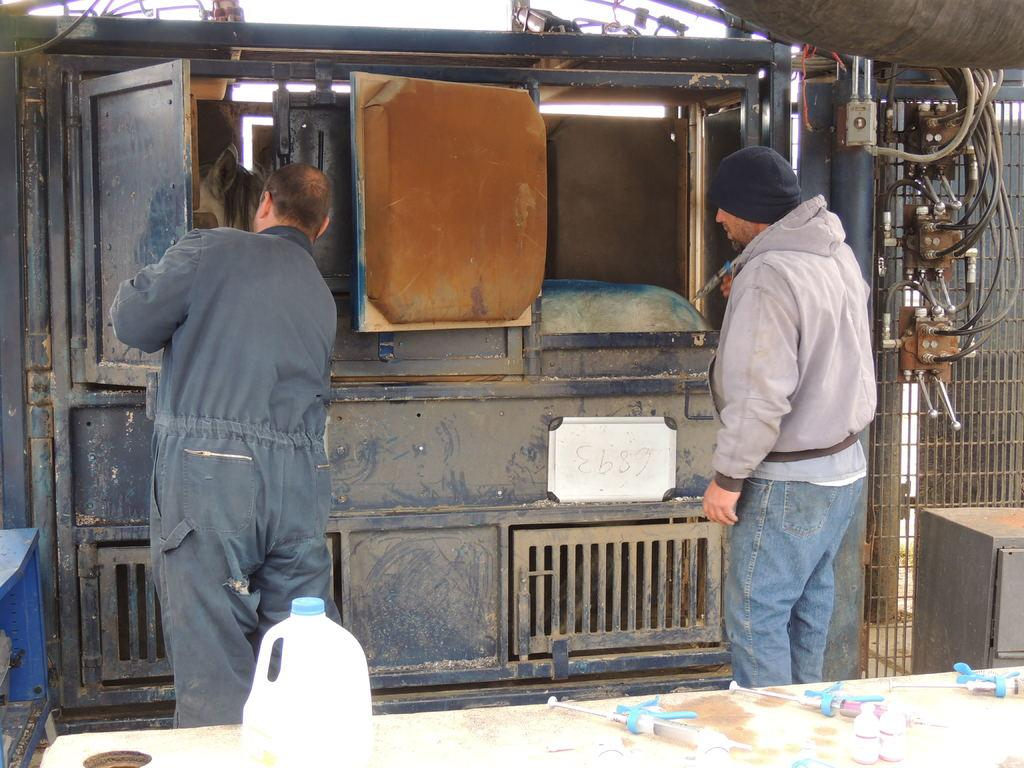What is the position of the man wearing a grey color dress in the image? The man wearing a grey color dress is standing on the left side of the image. Can you describe the clothing of the man on the left side? The man on the left side is wearing a grey color dress. What is the position of the other man in the image? The other man is standing on the right side of the image. Can you describe the clothing of the man on the right side? The man on the right side is wearing a coat, black color cap, and blue color jeans. What object can be seen at the bottom of the image? There is a can at the bottom of the image. What type of education does the man's mom have in the image? There is no mention of the man's mom in the image, so it is not possible to determine her level of education. 